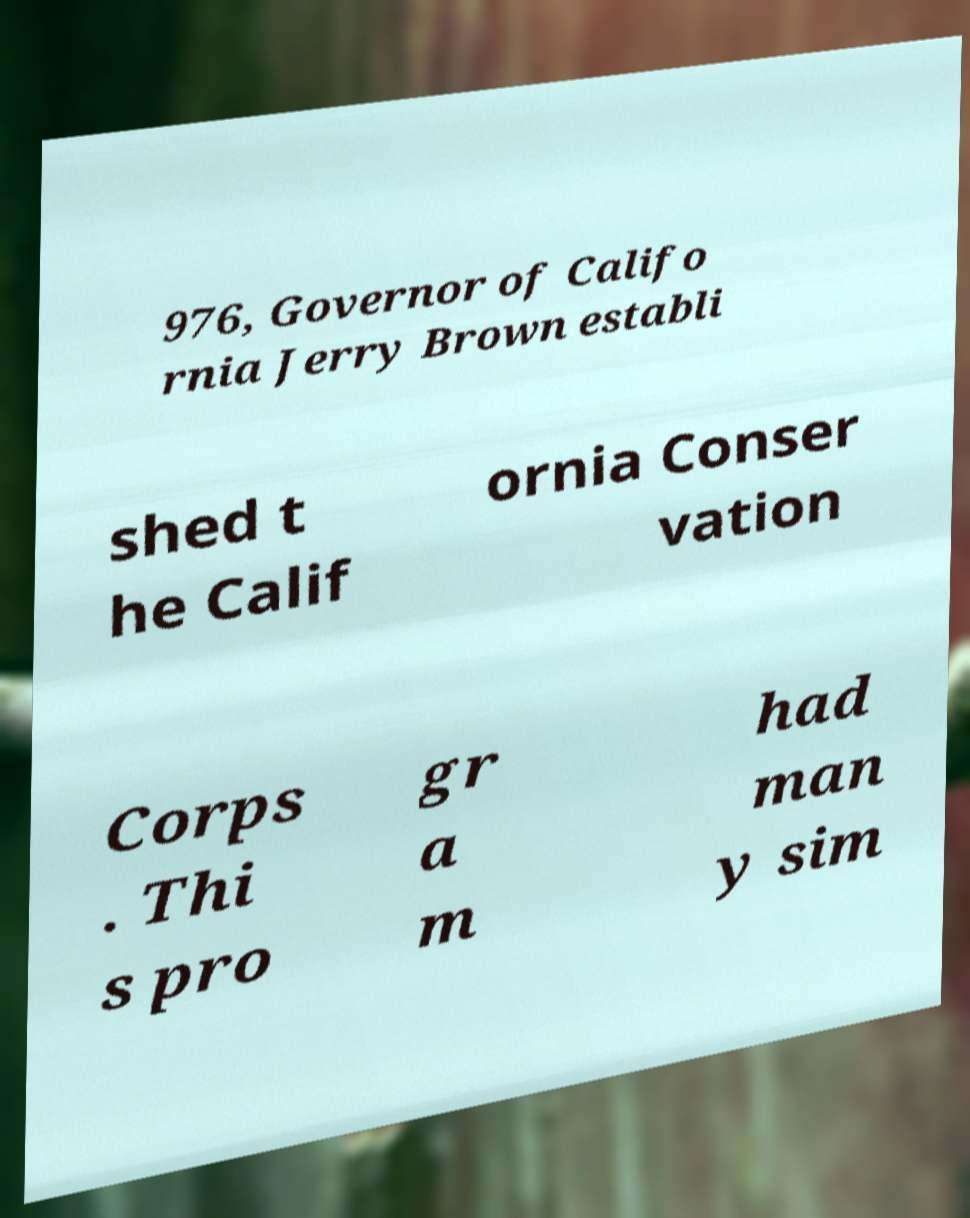There's text embedded in this image that I need extracted. Can you transcribe it verbatim? 976, Governor of Califo rnia Jerry Brown establi shed t he Calif ornia Conser vation Corps . Thi s pro gr a m had man y sim 